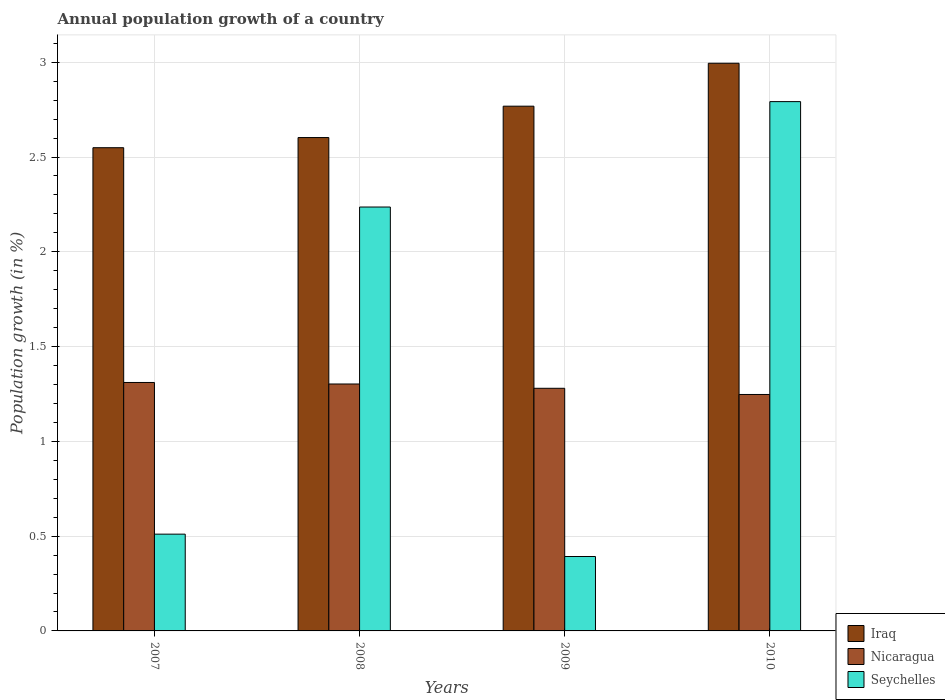How many groups of bars are there?
Provide a short and direct response. 4. Are the number of bars on each tick of the X-axis equal?
Offer a terse response. Yes. How many bars are there on the 2nd tick from the right?
Offer a very short reply. 3. What is the annual population growth in Seychelles in 2008?
Your answer should be compact. 2.24. Across all years, what is the maximum annual population growth in Seychelles?
Offer a terse response. 2.79. Across all years, what is the minimum annual population growth in Seychelles?
Offer a terse response. 0.39. In which year was the annual population growth in Iraq maximum?
Provide a succinct answer. 2010. What is the total annual population growth in Seychelles in the graph?
Give a very brief answer. 5.93. What is the difference between the annual population growth in Iraq in 2009 and that in 2010?
Provide a succinct answer. -0.23. What is the difference between the annual population growth in Nicaragua in 2008 and the annual population growth in Iraq in 2009?
Ensure brevity in your answer.  -1.47. What is the average annual population growth in Iraq per year?
Provide a short and direct response. 2.73. In the year 2010, what is the difference between the annual population growth in Seychelles and annual population growth in Nicaragua?
Ensure brevity in your answer.  1.54. What is the ratio of the annual population growth in Seychelles in 2008 to that in 2010?
Offer a terse response. 0.8. Is the annual population growth in Nicaragua in 2007 less than that in 2008?
Give a very brief answer. No. Is the difference between the annual population growth in Seychelles in 2009 and 2010 greater than the difference between the annual population growth in Nicaragua in 2009 and 2010?
Your answer should be compact. No. What is the difference between the highest and the second highest annual population growth in Seychelles?
Offer a terse response. 0.56. What is the difference between the highest and the lowest annual population growth in Iraq?
Provide a succinct answer. 0.45. Is the sum of the annual population growth in Seychelles in 2007 and 2009 greater than the maximum annual population growth in Nicaragua across all years?
Your response must be concise. No. What does the 2nd bar from the left in 2009 represents?
Make the answer very short. Nicaragua. What does the 2nd bar from the right in 2007 represents?
Offer a terse response. Nicaragua. Is it the case that in every year, the sum of the annual population growth in Iraq and annual population growth in Nicaragua is greater than the annual population growth in Seychelles?
Your response must be concise. Yes. How many bars are there?
Offer a terse response. 12. Are all the bars in the graph horizontal?
Offer a terse response. No. Are the values on the major ticks of Y-axis written in scientific E-notation?
Offer a terse response. No. Does the graph contain grids?
Your response must be concise. Yes. What is the title of the graph?
Provide a short and direct response. Annual population growth of a country. Does "St. Martin (French part)" appear as one of the legend labels in the graph?
Offer a terse response. No. What is the label or title of the Y-axis?
Your answer should be very brief. Population growth (in %). What is the Population growth (in %) of Iraq in 2007?
Offer a terse response. 2.55. What is the Population growth (in %) in Nicaragua in 2007?
Your answer should be compact. 1.31. What is the Population growth (in %) of Seychelles in 2007?
Your answer should be compact. 0.51. What is the Population growth (in %) in Iraq in 2008?
Offer a very short reply. 2.6. What is the Population growth (in %) in Nicaragua in 2008?
Ensure brevity in your answer.  1.3. What is the Population growth (in %) in Seychelles in 2008?
Keep it short and to the point. 2.24. What is the Population growth (in %) of Iraq in 2009?
Your answer should be very brief. 2.77. What is the Population growth (in %) in Nicaragua in 2009?
Your answer should be compact. 1.28. What is the Population growth (in %) in Seychelles in 2009?
Your answer should be very brief. 0.39. What is the Population growth (in %) of Iraq in 2010?
Provide a succinct answer. 2.99. What is the Population growth (in %) in Nicaragua in 2010?
Your response must be concise. 1.25. What is the Population growth (in %) of Seychelles in 2010?
Keep it short and to the point. 2.79. Across all years, what is the maximum Population growth (in %) in Iraq?
Give a very brief answer. 2.99. Across all years, what is the maximum Population growth (in %) in Nicaragua?
Make the answer very short. 1.31. Across all years, what is the maximum Population growth (in %) in Seychelles?
Ensure brevity in your answer.  2.79. Across all years, what is the minimum Population growth (in %) of Iraq?
Offer a very short reply. 2.55. Across all years, what is the minimum Population growth (in %) of Nicaragua?
Make the answer very short. 1.25. Across all years, what is the minimum Population growth (in %) in Seychelles?
Your answer should be very brief. 0.39. What is the total Population growth (in %) in Iraq in the graph?
Give a very brief answer. 10.91. What is the total Population growth (in %) in Nicaragua in the graph?
Your response must be concise. 5.14. What is the total Population growth (in %) of Seychelles in the graph?
Your answer should be very brief. 5.93. What is the difference between the Population growth (in %) of Iraq in 2007 and that in 2008?
Your answer should be compact. -0.05. What is the difference between the Population growth (in %) of Nicaragua in 2007 and that in 2008?
Keep it short and to the point. 0.01. What is the difference between the Population growth (in %) in Seychelles in 2007 and that in 2008?
Ensure brevity in your answer.  -1.73. What is the difference between the Population growth (in %) of Iraq in 2007 and that in 2009?
Your answer should be compact. -0.22. What is the difference between the Population growth (in %) of Nicaragua in 2007 and that in 2009?
Provide a succinct answer. 0.03. What is the difference between the Population growth (in %) of Seychelles in 2007 and that in 2009?
Make the answer very short. 0.12. What is the difference between the Population growth (in %) in Iraq in 2007 and that in 2010?
Your answer should be compact. -0.45. What is the difference between the Population growth (in %) of Nicaragua in 2007 and that in 2010?
Give a very brief answer. 0.06. What is the difference between the Population growth (in %) in Seychelles in 2007 and that in 2010?
Ensure brevity in your answer.  -2.28. What is the difference between the Population growth (in %) in Iraq in 2008 and that in 2009?
Your response must be concise. -0.17. What is the difference between the Population growth (in %) in Nicaragua in 2008 and that in 2009?
Your response must be concise. 0.02. What is the difference between the Population growth (in %) in Seychelles in 2008 and that in 2009?
Provide a succinct answer. 1.84. What is the difference between the Population growth (in %) of Iraq in 2008 and that in 2010?
Your answer should be compact. -0.39. What is the difference between the Population growth (in %) in Nicaragua in 2008 and that in 2010?
Your answer should be very brief. 0.06. What is the difference between the Population growth (in %) of Seychelles in 2008 and that in 2010?
Offer a terse response. -0.56. What is the difference between the Population growth (in %) of Iraq in 2009 and that in 2010?
Your answer should be very brief. -0.23. What is the difference between the Population growth (in %) of Nicaragua in 2009 and that in 2010?
Ensure brevity in your answer.  0.03. What is the difference between the Population growth (in %) of Seychelles in 2009 and that in 2010?
Offer a very short reply. -2.4. What is the difference between the Population growth (in %) in Iraq in 2007 and the Population growth (in %) in Nicaragua in 2008?
Offer a terse response. 1.25. What is the difference between the Population growth (in %) in Iraq in 2007 and the Population growth (in %) in Seychelles in 2008?
Your answer should be very brief. 0.31. What is the difference between the Population growth (in %) of Nicaragua in 2007 and the Population growth (in %) of Seychelles in 2008?
Your response must be concise. -0.93. What is the difference between the Population growth (in %) of Iraq in 2007 and the Population growth (in %) of Nicaragua in 2009?
Offer a very short reply. 1.27. What is the difference between the Population growth (in %) in Iraq in 2007 and the Population growth (in %) in Seychelles in 2009?
Keep it short and to the point. 2.16. What is the difference between the Population growth (in %) of Nicaragua in 2007 and the Population growth (in %) of Seychelles in 2009?
Make the answer very short. 0.92. What is the difference between the Population growth (in %) of Iraq in 2007 and the Population growth (in %) of Nicaragua in 2010?
Your answer should be compact. 1.3. What is the difference between the Population growth (in %) of Iraq in 2007 and the Population growth (in %) of Seychelles in 2010?
Provide a short and direct response. -0.24. What is the difference between the Population growth (in %) of Nicaragua in 2007 and the Population growth (in %) of Seychelles in 2010?
Your answer should be compact. -1.48. What is the difference between the Population growth (in %) in Iraq in 2008 and the Population growth (in %) in Nicaragua in 2009?
Your answer should be compact. 1.32. What is the difference between the Population growth (in %) in Iraq in 2008 and the Population growth (in %) in Seychelles in 2009?
Your answer should be very brief. 2.21. What is the difference between the Population growth (in %) of Nicaragua in 2008 and the Population growth (in %) of Seychelles in 2009?
Provide a succinct answer. 0.91. What is the difference between the Population growth (in %) of Iraq in 2008 and the Population growth (in %) of Nicaragua in 2010?
Your answer should be compact. 1.36. What is the difference between the Population growth (in %) of Iraq in 2008 and the Population growth (in %) of Seychelles in 2010?
Keep it short and to the point. -0.19. What is the difference between the Population growth (in %) in Nicaragua in 2008 and the Population growth (in %) in Seychelles in 2010?
Offer a very short reply. -1.49. What is the difference between the Population growth (in %) of Iraq in 2009 and the Population growth (in %) of Nicaragua in 2010?
Your answer should be very brief. 1.52. What is the difference between the Population growth (in %) in Iraq in 2009 and the Population growth (in %) in Seychelles in 2010?
Provide a succinct answer. -0.02. What is the difference between the Population growth (in %) of Nicaragua in 2009 and the Population growth (in %) of Seychelles in 2010?
Provide a short and direct response. -1.51. What is the average Population growth (in %) in Iraq per year?
Your response must be concise. 2.73. What is the average Population growth (in %) in Nicaragua per year?
Provide a succinct answer. 1.29. What is the average Population growth (in %) of Seychelles per year?
Ensure brevity in your answer.  1.48. In the year 2007, what is the difference between the Population growth (in %) in Iraq and Population growth (in %) in Nicaragua?
Ensure brevity in your answer.  1.24. In the year 2007, what is the difference between the Population growth (in %) in Iraq and Population growth (in %) in Seychelles?
Your answer should be compact. 2.04. In the year 2007, what is the difference between the Population growth (in %) of Nicaragua and Population growth (in %) of Seychelles?
Your answer should be compact. 0.8. In the year 2008, what is the difference between the Population growth (in %) in Iraq and Population growth (in %) in Nicaragua?
Provide a short and direct response. 1.3. In the year 2008, what is the difference between the Population growth (in %) of Iraq and Population growth (in %) of Seychelles?
Provide a short and direct response. 0.37. In the year 2008, what is the difference between the Population growth (in %) of Nicaragua and Population growth (in %) of Seychelles?
Make the answer very short. -0.93. In the year 2009, what is the difference between the Population growth (in %) in Iraq and Population growth (in %) in Nicaragua?
Offer a terse response. 1.49. In the year 2009, what is the difference between the Population growth (in %) of Iraq and Population growth (in %) of Seychelles?
Provide a succinct answer. 2.38. In the year 2009, what is the difference between the Population growth (in %) in Nicaragua and Population growth (in %) in Seychelles?
Make the answer very short. 0.89. In the year 2010, what is the difference between the Population growth (in %) in Iraq and Population growth (in %) in Nicaragua?
Keep it short and to the point. 1.75. In the year 2010, what is the difference between the Population growth (in %) in Iraq and Population growth (in %) in Seychelles?
Your response must be concise. 0.2. In the year 2010, what is the difference between the Population growth (in %) of Nicaragua and Population growth (in %) of Seychelles?
Give a very brief answer. -1.54. What is the ratio of the Population growth (in %) of Iraq in 2007 to that in 2008?
Your answer should be very brief. 0.98. What is the ratio of the Population growth (in %) in Nicaragua in 2007 to that in 2008?
Give a very brief answer. 1.01. What is the ratio of the Population growth (in %) of Seychelles in 2007 to that in 2008?
Offer a terse response. 0.23. What is the ratio of the Population growth (in %) of Iraq in 2007 to that in 2009?
Offer a terse response. 0.92. What is the ratio of the Population growth (in %) in Nicaragua in 2007 to that in 2009?
Offer a very short reply. 1.02. What is the ratio of the Population growth (in %) of Seychelles in 2007 to that in 2009?
Provide a succinct answer. 1.3. What is the ratio of the Population growth (in %) in Iraq in 2007 to that in 2010?
Provide a short and direct response. 0.85. What is the ratio of the Population growth (in %) in Nicaragua in 2007 to that in 2010?
Keep it short and to the point. 1.05. What is the ratio of the Population growth (in %) in Seychelles in 2007 to that in 2010?
Offer a terse response. 0.18. What is the ratio of the Population growth (in %) of Iraq in 2008 to that in 2009?
Your response must be concise. 0.94. What is the ratio of the Population growth (in %) of Nicaragua in 2008 to that in 2009?
Your response must be concise. 1.02. What is the ratio of the Population growth (in %) of Seychelles in 2008 to that in 2009?
Ensure brevity in your answer.  5.7. What is the ratio of the Population growth (in %) in Iraq in 2008 to that in 2010?
Provide a succinct answer. 0.87. What is the ratio of the Population growth (in %) of Nicaragua in 2008 to that in 2010?
Make the answer very short. 1.04. What is the ratio of the Population growth (in %) in Seychelles in 2008 to that in 2010?
Your answer should be very brief. 0.8. What is the ratio of the Population growth (in %) of Iraq in 2009 to that in 2010?
Give a very brief answer. 0.92. What is the ratio of the Population growth (in %) in Nicaragua in 2009 to that in 2010?
Offer a terse response. 1.03. What is the ratio of the Population growth (in %) in Seychelles in 2009 to that in 2010?
Provide a succinct answer. 0.14. What is the difference between the highest and the second highest Population growth (in %) in Iraq?
Ensure brevity in your answer.  0.23. What is the difference between the highest and the second highest Population growth (in %) of Nicaragua?
Keep it short and to the point. 0.01. What is the difference between the highest and the second highest Population growth (in %) of Seychelles?
Give a very brief answer. 0.56. What is the difference between the highest and the lowest Population growth (in %) of Iraq?
Offer a very short reply. 0.45. What is the difference between the highest and the lowest Population growth (in %) of Nicaragua?
Make the answer very short. 0.06. What is the difference between the highest and the lowest Population growth (in %) of Seychelles?
Keep it short and to the point. 2.4. 